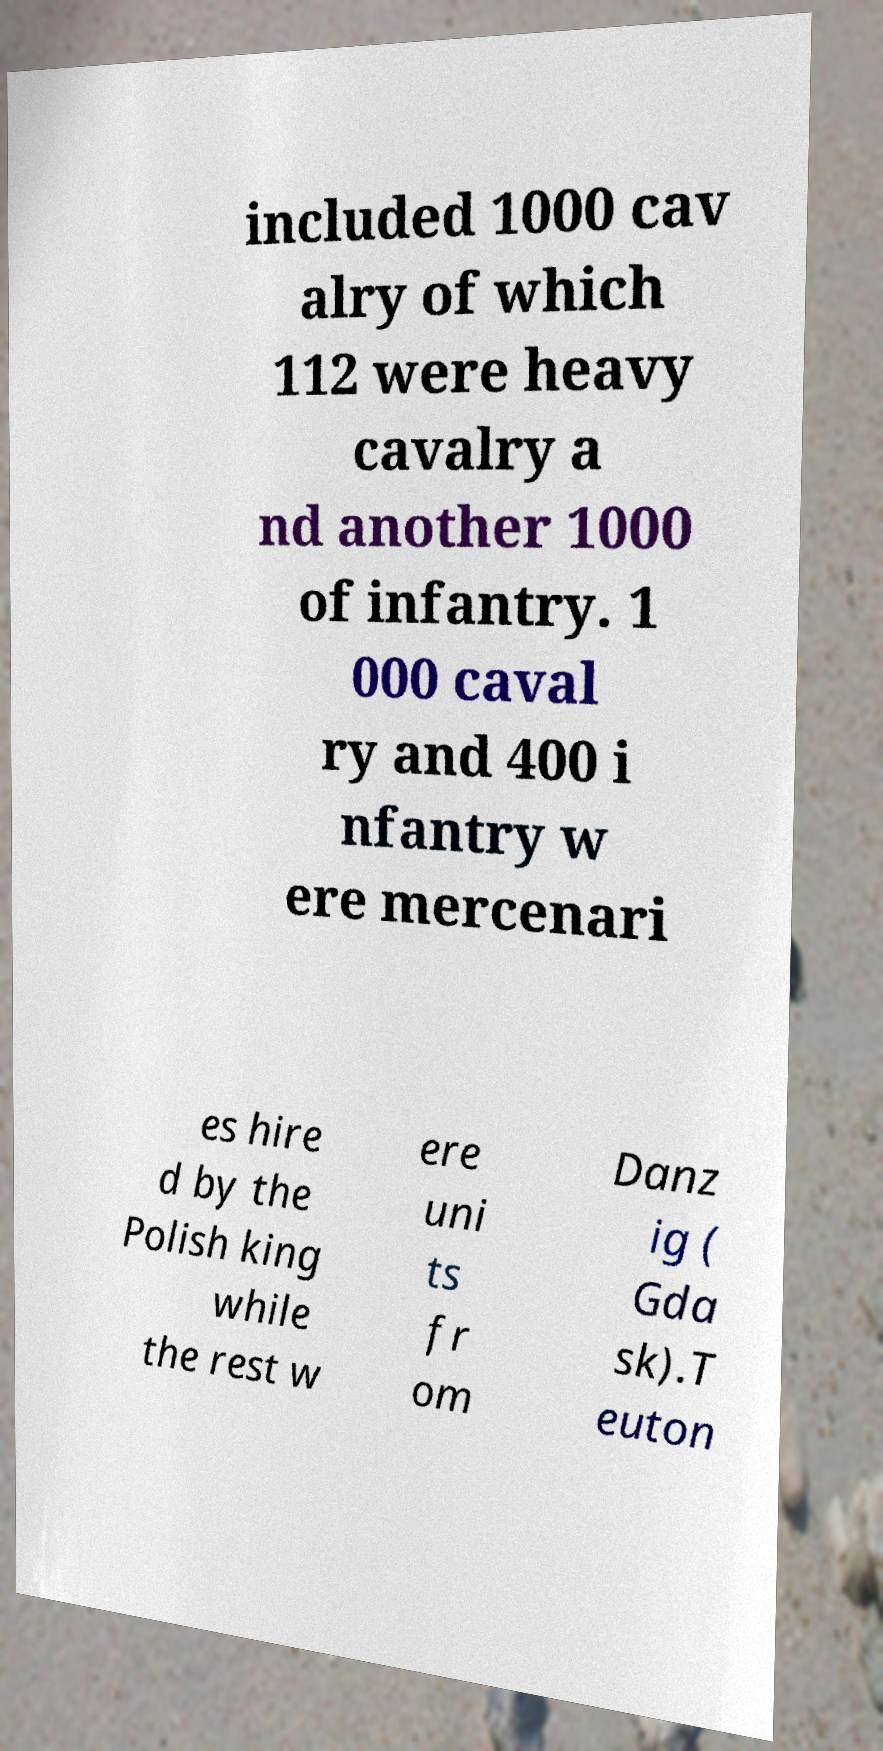Please read and relay the text visible in this image. What does it say? included 1000 cav alry of which 112 were heavy cavalry a nd another 1000 of infantry. 1 000 caval ry and 400 i nfantry w ere mercenari es hire d by the Polish king while the rest w ere uni ts fr om Danz ig ( Gda sk).T euton 